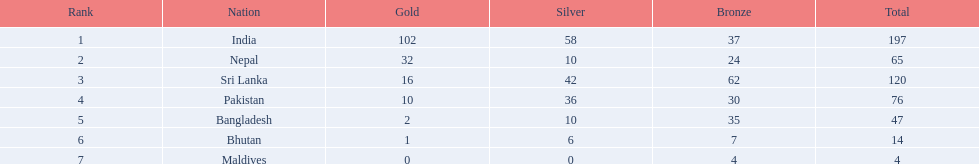In the 1999 south asian games, which countries were the participants? India, Nepal, Sri Lanka, Pakistan, Bangladesh, Bhutan, Maldives. Which nation is ranked second in the table? Nepal. 